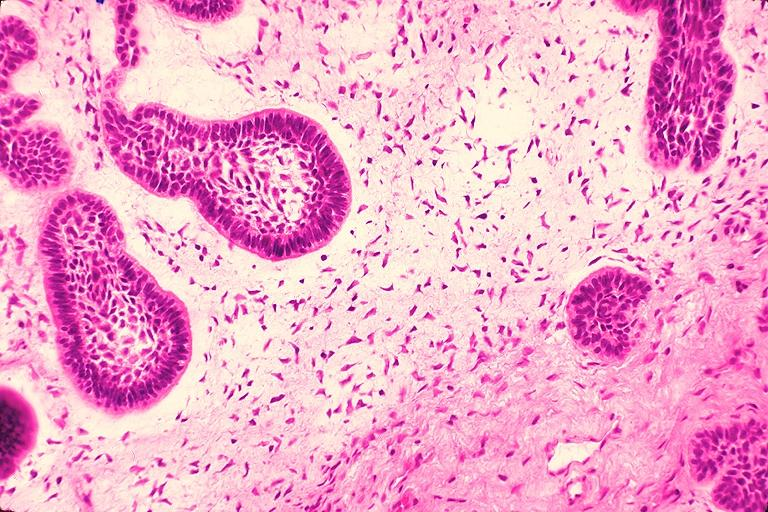s oral present?
Answer the question using a single word or phrase. Yes 